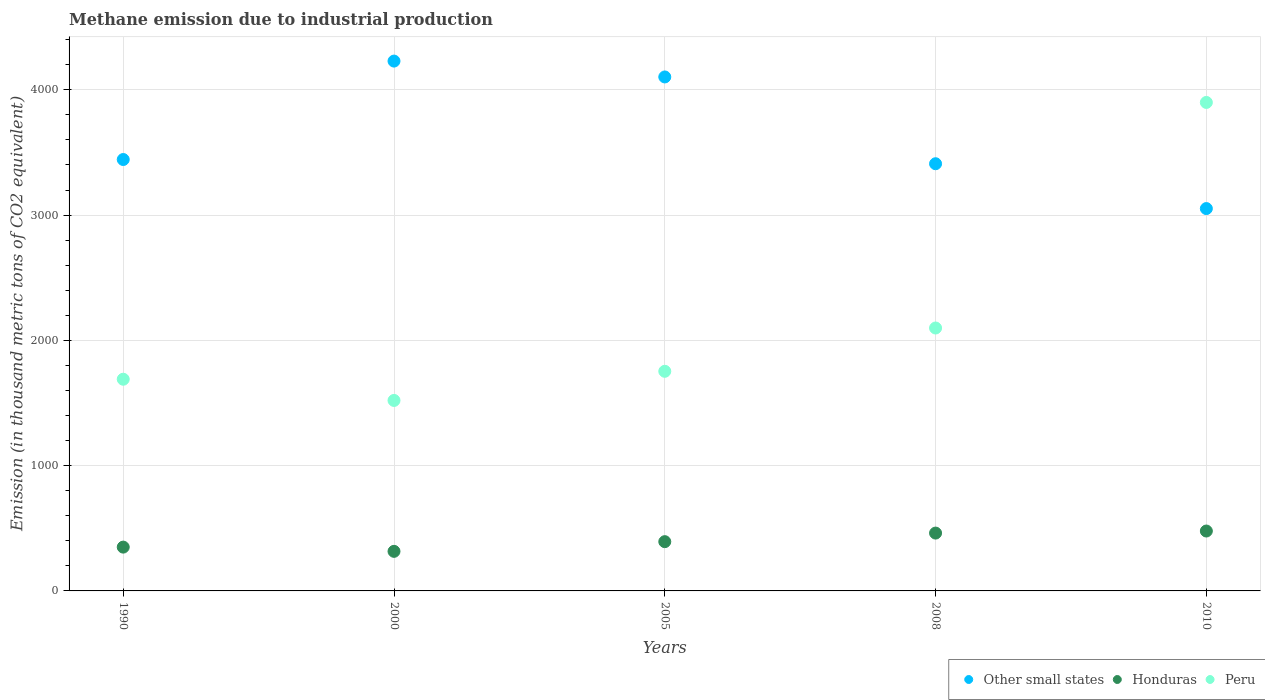Is the number of dotlines equal to the number of legend labels?
Make the answer very short. Yes. What is the amount of methane emitted in Peru in 2000?
Make the answer very short. 1520.5. Across all years, what is the maximum amount of methane emitted in Other small states?
Your answer should be compact. 4229.4. Across all years, what is the minimum amount of methane emitted in Peru?
Your response must be concise. 1520.5. What is the total amount of methane emitted in Peru in the graph?
Keep it short and to the point. 1.10e+04. What is the difference between the amount of methane emitted in Other small states in 2000 and that in 2010?
Keep it short and to the point. 1177.3. What is the difference between the amount of methane emitted in Honduras in 2000 and the amount of methane emitted in Other small states in 2005?
Offer a terse response. -3786.9. What is the average amount of methane emitted in Other small states per year?
Provide a succinct answer. 3647.6. In the year 2010, what is the difference between the amount of methane emitted in Honduras and amount of methane emitted in Peru?
Provide a short and direct response. -3421.2. What is the ratio of the amount of methane emitted in Other small states in 1990 to that in 2010?
Provide a succinct answer. 1.13. Is the amount of methane emitted in Other small states in 1990 less than that in 2008?
Give a very brief answer. No. What is the difference between the highest and the second highest amount of methane emitted in Honduras?
Give a very brief answer. 16.4. What is the difference between the highest and the lowest amount of methane emitted in Other small states?
Offer a terse response. 1177.3. In how many years, is the amount of methane emitted in Other small states greater than the average amount of methane emitted in Other small states taken over all years?
Offer a very short reply. 2. Is the sum of the amount of methane emitted in Other small states in 1990 and 2000 greater than the maximum amount of methane emitted in Honduras across all years?
Your response must be concise. Yes. Is the amount of methane emitted in Peru strictly less than the amount of methane emitted in Other small states over the years?
Offer a terse response. No. How many dotlines are there?
Keep it short and to the point. 3. How are the legend labels stacked?
Offer a terse response. Horizontal. What is the title of the graph?
Offer a very short reply. Methane emission due to industrial production. Does "St. Martin (French part)" appear as one of the legend labels in the graph?
Make the answer very short. No. What is the label or title of the Y-axis?
Ensure brevity in your answer.  Emission (in thousand metric tons of CO2 equivalent). What is the Emission (in thousand metric tons of CO2 equivalent) in Other small states in 1990?
Provide a succinct answer. 3443.7. What is the Emission (in thousand metric tons of CO2 equivalent) in Honduras in 1990?
Your answer should be very brief. 349.7. What is the Emission (in thousand metric tons of CO2 equivalent) of Peru in 1990?
Offer a very short reply. 1689.8. What is the Emission (in thousand metric tons of CO2 equivalent) of Other small states in 2000?
Your response must be concise. 4229.4. What is the Emission (in thousand metric tons of CO2 equivalent) of Honduras in 2000?
Offer a terse response. 315.9. What is the Emission (in thousand metric tons of CO2 equivalent) of Peru in 2000?
Your answer should be very brief. 1520.5. What is the Emission (in thousand metric tons of CO2 equivalent) of Other small states in 2005?
Provide a short and direct response. 4102.8. What is the Emission (in thousand metric tons of CO2 equivalent) of Honduras in 2005?
Provide a short and direct response. 393.2. What is the Emission (in thousand metric tons of CO2 equivalent) of Peru in 2005?
Provide a short and direct response. 1753.1. What is the Emission (in thousand metric tons of CO2 equivalent) of Other small states in 2008?
Your answer should be very brief. 3410. What is the Emission (in thousand metric tons of CO2 equivalent) of Honduras in 2008?
Keep it short and to the point. 461.7. What is the Emission (in thousand metric tons of CO2 equivalent) of Peru in 2008?
Give a very brief answer. 2098.7. What is the Emission (in thousand metric tons of CO2 equivalent) in Other small states in 2010?
Your answer should be compact. 3052.1. What is the Emission (in thousand metric tons of CO2 equivalent) in Honduras in 2010?
Your answer should be very brief. 478.1. What is the Emission (in thousand metric tons of CO2 equivalent) of Peru in 2010?
Your response must be concise. 3899.3. Across all years, what is the maximum Emission (in thousand metric tons of CO2 equivalent) in Other small states?
Keep it short and to the point. 4229.4. Across all years, what is the maximum Emission (in thousand metric tons of CO2 equivalent) of Honduras?
Make the answer very short. 478.1. Across all years, what is the maximum Emission (in thousand metric tons of CO2 equivalent) of Peru?
Provide a short and direct response. 3899.3. Across all years, what is the minimum Emission (in thousand metric tons of CO2 equivalent) in Other small states?
Offer a terse response. 3052.1. Across all years, what is the minimum Emission (in thousand metric tons of CO2 equivalent) in Honduras?
Your answer should be very brief. 315.9. Across all years, what is the minimum Emission (in thousand metric tons of CO2 equivalent) of Peru?
Provide a succinct answer. 1520.5. What is the total Emission (in thousand metric tons of CO2 equivalent) of Other small states in the graph?
Your answer should be very brief. 1.82e+04. What is the total Emission (in thousand metric tons of CO2 equivalent) in Honduras in the graph?
Provide a succinct answer. 1998.6. What is the total Emission (in thousand metric tons of CO2 equivalent) in Peru in the graph?
Provide a succinct answer. 1.10e+04. What is the difference between the Emission (in thousand metric tons of CO2 equivalent) in Other small states in 1990 and that in 2000?
Ensure brevity in your answer.  -785.7. What is the difference between the Emission (in thousand metric tons of CO2 equivalent) of Honduras in 1990 and that in 2000?
Make the answer very short. 33.8. What is the difference between the Emission (in thousand metric tons of CO2 equivalent) of Peru in 1990 and that in 2000?
Your answer should be very brief. 169.3. What is the difference between the Emission (in thousand metric tons of CO2 equivalent) in Other small states in 1990 and that in 2005?
Give a very brief answer. -659.1. What is the difference between the Emission (in thousand metric tons of CO2 equivalent) in Honduras in 1990 and that in 2005?
Provide a short and direct response. -43.5. What is the difference between the Emission (in thousand metric tons of CO2 equivalent) of Peru in 1990 and that in 2005?
Make the answer very short. -63.3. What is the difference between the Emission (in thousand metric tons of CO2 equivalent) in Other small states in 1990 and that in 2008?
Ensure brevity in your answer.  33.7. What is the difference between the Emission (in thousand metric tons of CO2 equivalent) in Honduras in 1990 and that in 2008?
Ensure brevity in your answer.  -112. What is the difference between the Emission (in thousand metric tons of CO2 equivalent) in Peru in 1990 and that in 2008?
Ensure brevity in your answer.  -408.9. What is the difference between the Emission (in thousand metric tons of CO2 equivalent) in Other small states in 1990 and that in 2010?
Offer a very short reply. 391.6. What is the difference between the Emission (in thousand metric tons of CO2 equivalent) of Honduras in 1990 and that in 2010?
Ensure brevity in your answer.  -128.4. What is the difference between the Emission (in thousand metric tons of CO2 equivalent) of Peru in 1990 and that in 2010?
Ensure brevity in your answer.  -2209.5. What is the difference between the Emission (in thousand metric tons of CO2 equivalent) in Other small states in 2000 and that in 2005?
Offer a very short reply. 126.6. What is the difference between the Emission (in thousand metric tons of CO2 equivalent) in Honduras in 2000 and that in 2005?
Your answer should be very brief. -77.3. What is the difference between the Emission (in thousand metric tons of CO2 equivalent) in Peru in 2000 and that in 2005?
Your answer should be very brief. -232.6. What is the difference between the Emission (in thousand metric tons of CO2 equivalent) in Other small states in 2000 and that in 2008?
Provide a succinct answer. 819.4. What is the difference between the Emission (in thousand metric tons of CO2 equivalent) in Honduras in 2000 and that in 2008?
Offer a terse response. -145.8. What is the difference between the Emission (in thousand metric tons of CO2 equivalent) in Peru in 2000 and that in 2008?
Offer a terse response. -578.2. What is the difference between the Emission (in thousand metric tons of CO2 equivalent) in Other small states in 2000 and that in 2010?
Offer a terse response. 1177.3. What is the difference between the Emission (in thousand metric tons of CO2 equivalent) of Honduras in 2000 and that in 2010?
Make the answer very short. -162.2. What is the difference between the Emission (in thousand metric tons of CO2 equivalent) in Peru in 2000 and that in 2010?
Offer a terse response. -2378.8. What is the difference between the Emission (in thousand metric tons of CO2 equivalent) in Other small states in 2005 and that in 2008?
Your answer should be very brief. 692.8. What is the difference between the Emission (in thousand metric tons of CO2 equivalent) of Honduras in 2005 and that in 2008?
Your answer should be very brief. -68.5. What is the difference between the Emission (in thousand metric tons of CO2 equivalent) of Peru in 2005 and that in 2008?
Ensure brevity in your answer.  -345.6. What is the difference between the Emission (in thousand metric tons of CO2 equivalent) in Other small states in 2005 and that in 2010?
Your response must be concise. 1050.7. What is the difference between the Emission (in thousand metric tons of CO2 equivalent) in Honduras in 2005 and that in 2010?
Your response must be concise. -84.9. What is the difference between the Emission (in thousand metric tons of CO2 equivalent) in Peru in 2005 and that in 2010?
Your response must be concise. -2146.2. What is the difference between the Emission (in thousand metric tons of CO2 equivalent) of Other small states in 2008 and that in 2010?
Offer a terse response. 357.9. What is the difference between the Emission (in thousand metric tons of CO2 equivalent) in Honduras in 2008 and that in 2010?
Your answer should be compact. -16.4. What is the difference between the Emission (in thousand metric tons of CO2 equivalent) of Peru in 2008 and that in 2010?
Your answer should be compact. -1800.6. What is the difference between the Emission (in thousand metric tons of CO2 equivalent) in Other small states in 1990 and the Emission (in thousand metric tons of CO2 equivalent) in Honduras in 2000?
Ensure brevity in your answer.  3127.8. What is the difference between the Emission (in thousand metric tons of CO2 equivalent) in Other small states in 1990 and the Emission (in thousand metric tons of CO2 equivalent) in Peru in 2000?
Make the answer very short. 1923.2. What is the difference between the Emission (in thousand metric tons of CO2 equivalent) of Honduras in 1990 and the Emission (in thousand metric tons of CO2 equivalent) of Peru in 2000?
Offer a terse response. -1170.8. What is the difference between the Emission (in thousand metric tons of CO2 equivalent) of Other small states in 1990 and the Emission (in thousand metric tons of CO2 equivalent) of Honduras in 2005?
Give a very brief answer. 3050.5. What is the difference between the Emission (in thousand metric tons of CO2 equivalent) of Other small states in 1990 and the Emission (in thousand metric tons of CO2 equivalent) of Peru in 2005?
Your answer should be very brief. 1690.6. What is the difference between the Emission (in thousand metric tons of CO2 equivalent) in Honduras in 1990 and the Emission (in thousand metric tons of CO2 equivalent) in Peru in 2005?
Your response must be concise. -1403.4. What is the difference between the Emission (in thousand metric tons of CO2 equivalent) in Other small states in 1990 and the Emission (in thousand metric tons of CO2 equivalent) in Honduras in 2008?
Offer a terse response. 2982. What is the difference between the Emission (in thousand metric tons of CO2 equivalent) in Other small states in 1990 and the Emission (in thousand metric tons of CO2 equivalent) in Peru in 2008?
Your response must be concise. 1345. What is the difference between the Emission (in thousand metric tons of CO2 equivalent) of Honduras in 1990 and the Emission (in thousand metric tons of CO2 equivalent) of Peru in 2008?
Your answer should be compact. -1749. What is the difference between the Emission (in thousand metric tons of CO2 equivalent) of Other small states in 1990 and the Emission (in thousand metric tons of CO2 equivalent) of Honduras in 2010?
Provide a succinct answer. 2965.6. What is the difference between the Emission (in thousand metric tons of CO2 equivalent) in Other small states in 1990 and the Emission (in thousand metric tons of CO2 equivalent) in Peru in 2010?
Offer a very short reply. -455.6. What is the difference between the Emission (in thousand metric tons of CO2 equivalent) of Honduras in 1990 and the Emission (in thousand metric tons of CO2 equivalent) of Peru in 2010?
Provide a succinct answer. -3549.6. What is the difference between the Emission (in thousand metric tons of CO2 equivalent) of Other small states in 2000 and the Emission (in thousand metric tons of CO2 equivalent) of Honduras in 2005?
Make the answer very short. 3836.2. What is the difference between the Emission (in thousand metric tons of CO2 equivalent) in Other small states in 2000 and the Emission (in thousand metric tons of CO2 equivalent) in Peru in 2005?
Offer a very short reply. 2476.3. What is the difference between the Emission (in thousand metric tons of CO2 equivalent) in Honduras in 2000 and the Emission (in thousand metric tons of CO2 equivalent) in Peru in 2005?
Provide a succinct answer. -1437.2. What is the difference between the Emission (in thousand metric tons of CO2 equivalent) of Other small states in 2000 and the Emission (in thousand metric tons of CO2 equivalent) of Honduras in 2008?
Ensure brevity in your answer.  3767.7. What is the difference between the Emission (in thousand metric tons of CO2 equivalent) of Other small states in 2000 and the Emission (in thousand metric tons of CO2 equivalent) of Peru in 2008?
Provide a succinct answer. 2130.7. What is the difference between the Emission (in thousand metric tons of CO2 equivalent) of Honduras in 2000 and the Emission (in thousand metric tons of CO2 equivalent) of Peru in 2008?
Offer a very short reply. -1782.8. What is the difference between the Emission (in thousand metric tons of CO2 equivalent) in Other small states in 2000 and the Emission (in thousand metric tons of CO2 equivalent) in Honduras in 2010?
Your answer should be compact. 3751.3. What is the difference between the Emission (in thousand metric tons of CO2 equivalent) of Other small states in 2000 and the Emission (in thousand metric tons of CO2 equivalent) of Peru in 2010?
Your response must be concise. 330.1. What is the difference between the Emission (in thousand metric tons of CO2 equivalent) in Honduras in 2000 and the Emission (in thousand metric tons of CO2 equivalent) in Peru in 2010?
Your answer should be very brief. -3583.4. What is the difference between the Emission (in thousand metric tons of CO2 equivalent) in Other small states in 2005 and the Emission (in thousand metric tons of CO2 equivalent) in Honduras in 2008?
Ensure brevity in your answer.  3641.1. What is the difference between the Emission (in thousand metric tons of CO2 equivalent) of Other small states in 2005 and the Emission (in thousand metric tons of CO2 equivalent) of Peru in 2008?
Your answer should be very brief. 2004.1. What is the difference between the Emission (in thousand metric tons of CO2 equivalent) of Honduras in 2005 and the Emission (in thousand metric tons of CO2 equivalent) of Peru in 2008?
Make the answer very short. -1705.5. What is the difference between the Emission (in thousand metric tons of CO2 equivalent) of Other small states in 2005 and the Emission (in thousand metric tons of CO2 equivalent) of Honduras in 2010?
Ensure brevity in your answer.  3624.7. What is the difference between the Emission (in thousand metric tons of CO2 equivalent) in Other small states in 2005 and the Emission (in thousand metric tons of CO2 equivalent) in Peru in 2010?
Provide a succinct answer. 203.5. What is the difference between the Emission (in thousand metric tons of CO2 equivalent) of Honduras in 2005 and the Emission (in thousand metric tons of CO2 equivalent) of Peru in 2010?
Give a very brief answer. -3506.1. What is the difference between the Emission (in thousand metric tons of CO2 equivalent) of Other small states in 2008 and the Emission (in thousand metric tons of CO2 equivalent) of Honduras in 2010?
Provide a short and direct response. 2931.9. What is the difference between the Emission (in thousand metric tons of CO2 equivalent) of Other small states in 2008 and the Emission (in thousand metric tons of CO2 equivalent) of Peru in 2010?
Make the answer very short. -489.3. What is the difference between the Emission (in thousand metric tons of CO2 equivalent) of Honduras in 2008 and the Emission (in thousand metric tons of CO2 equivalent) of Peru in 2010?
Offer a terse response. -3437.6. What is the average Emission (in thousand metric tons of CO2 equivalent) of Other small states per year?
Make the answer very short. 3647.6. What is the average Emission (in thousand metric tons of CO2 equivalent) in Honduras per year?
Your response must be concise. 399.72. What is the average Emission (in thousand metric tons of CO2 equivalent) in Peru per year?
Keep it short and to the point. 2192.28. In the year 1990, what is the difference between the Emission (in thousand metric tons of CO2 equivalent) in Other small states and Emission (in thousand metric tons of CO2 equivalent) in Honduras?
Give a very brief answer. 3094. In the year 1990, what is the difference between the Emission (in thousand metric tons of CO2 equivalent) in Other small states and Emission (in thousand metric tons of CO2 equivalent) in Peru?
Offer a terse response. 1753.9. In the year 1990, what is the difference between the Emission (in thousand metric tons of CO2 equivalent) in Honduras and Emission (in thousand metric tons of CO2 equivalent) in Peru?
Give a very brief answer. -1340.1. In the year 2000, what is the difference between the Emission (in thousand metric tons of CO2 equivalent) of Other small states and Emission (in thousand metric tons of CO2 equivalent) of Honduras?
Make the answer very short. 3913.5. In the year 2000, what is the difference between the Emission (in thousand metric tons of CO2 equivalent) of Other small states and Emission (in thousand metric tons of CO2 equivalent) of Peru?
Make the answer very short. 2708.9. In the year 2000, what is the difference between the Emission (in thousand metric tons of CO2 equivalent) of Honduras and Emission (in thousand metric tons of CO2 equivalent) of Peru?
Offer a terse response. -1204.6. In the year 2005, what is the difference between the Emission (in thousand metric tons of CO2 equivalent) of Other small states and Emission (in thousand metric tons of CO2 equivalent) of Honduras?
Keep it short and to the point. 3709.6. In the year 2005, what is the difference between the Emission (in thousand metric tons of CO2 equivalent) of Other small states and Emission (in thousand metric tons of CO2 equivalent) of Peru?
Make the answer very short. 2349.7. In the year 2005, what is the difference between the Emission (in thousand metric tons of CO2 equivalent) of Honduras and Emission (in thousand metric tons of CO2 equivalent) of Peru?
Provide a succinct answer. -1359.9. In the year 2008, what is the difference between the Emission (in thousand metric tons of CO2 equivalent) of Other small states and Emission (in thousand metric tons of CO2 equivalent) of Honduras?
Your response must be concise. 2948.3. In the year 2008, what is the difference between the Emission (in thousand metric tons of CO2 equivalent) of Other small states and Emission (in thousand metric tons of CO2 equivalent) of Peru?
Your answer should be compact. 1311.3. In the year 2008, what is the difference between the Emission (in thousand metric tons of CO2 equivalent) in Honduras and Emission (in thousand metric tons of CO2 equivalent) in Peru?
Offer a terse response. -1637. In the year 2010, what is the difference between the Emission (in thousand metric tons of CO2 equivalent) in Other small states and Emission (in thousand metric tons of CO2 equivalent) in Honduras?
Give a very brief answer. 2574. In the year 2010, what is the difference between the Emission (in thousand metric tons of CO2 equivalent) in Other small states and Emission (in thousand metric tons of CO2 equivalent) in Peru?
Your answer should be compact. -847.2. In the year 2010, what is the difference between the Emission (in thousand metric tons of CO2 equivalent) in Honduras and Emission (in thousand metric tons of CO2 equivalent) in Peru?
Your answer should be compact. -3421.2. What is the ratio of the Emission (in thousand metric tons of CO2 equivalent) in Other small states in 1990 to that in 2000?
Ensure brevity in your answer.  0.81. What is the ratio of the Emission (in thousand metric tons of CO2 equivalent) in Honduras in 1990 to that in 2000?
Keep it short and to the point. 1.11. What is the ratio of the Emission (in thousand metric tons of CO2 equivalent) of Peru in 1990 to that in 2000?
Your answer should be compact. 1.11. What is the ratio of the Emission (in thousand metric tons of CO2 equivalent) of Other small states in 1990 to that in 2005?
Offer a very short reply. 0.84. What is the ratio of the Emission (in thousand metric tons of CO2 equivalent) in Honduras in 1990 to that in 2005?
Your answer should be very brief. 0.89. What is the ratio of the Emission (in thousand metric tons of CO2 equivalent) in Peru in 1990 to that in 2005?
Your response must be concise. 0.96. What is the ratio of the Emission (in thousand metric tons of CO2 equivalent) of Other small states in 1990 to that in 2008?
Offer a terse response. 1.01. What is the ratio of the Emission (in thousand metric tons of CO2 equivalent) of Honduras in 1990 to that in 2008?
Make the answer very short. 0.76. What is the ratio of the Emission (in thousand metric tons of CO2 equivalent) in Peru in 1990 to that in 2008?
Offer a terse response. 0.81. What is the ratio of the Emission (in thousand metric tons of CO2 equivalent) of Other small states in 1990 to that in 2010?
Provide a succinct answer. 1.13. What is the ratio of the Emission (in thousand metric tons of CO2 equivalent) in Honduras in 1990 to that in 2010?
Provide a short and direct response. 0.73. What is the ratio of the Emission (in thousand metric tons of CO2 equivalent) of Peru in 1990 to that in 2010?
Your answer should be very brief. 0.43. What is the ratio of the Emission (in thousand metric tons of CO2 equivalent) in Other small states in 2000 to that in 2005?
Provide a succinct answer. 1.03. What is the ratio of the Emission (in thousand metric tons of CO2 equivalent) of Honduras in 2000 to that in 2005?
Give a very brief answer. 0.8. What is the ratio of the Emission (in thousand metric tons of CO2 equivalent) of Peru in 2000 to that in 2005?
Offer a very short reply. 0.87. What is the ratio of the Emission (in thousand metric tons of CO2 equivalent) in Other small states in 2000 to that in 2008?
Your response must be concise. 1.24. What is the ratio of the Emission (in thousand metric tons of CO2 equivalent) in Honduras in 2000 to that in 2008?
Ensure brevity in your answer.  0.68. What is the ratio of the Emission (in thousand metric tons of CO2 equivalent) in Peru in 2000 to that in 2008?
Your answer should be very brief. 0.72. What is the ratio of the Emission (in thousand metric tons of CO2 equivalent) of Other small states in 2000 to that in 2010?
Your answer should be compact. 1.39. What is the ratio of the Emission (in thousand metric tons of CO2 equivalent) of Honduras in 2000 to that in 2010?
Your answer should be very brief. 0.66. What is the ratio of the Emission (in thousand metric tons of CO2 equivalent) in Peru in 2000 to that in 2010?
Your answer should be very brief. 0.39. What is the ratio of the Emission (in thousand metric tons of CO2 equivalent) in Other small states in 2005 to that in 2008?
Your response must be concise. 1.2. What is the ratio of the Emission (in thousand metric tons of CO2 equivalent) of Honduras in 2005 to that in 2008?
Provide a short and direct response. 0.85. What is the ratio of the Emission (in thousand metric tons of CO2 equivalent) of Peru in 2005 to that in 2008?
Ensure brevity in your answer.  0.84. What is the ratio of the Emission (in thousand metric tons of CO2 equivalent) of Other small states in 2005 to that in 2010?
Give a very brief answer. 1.34. What is the ratio of the Emission (in thousand metric tons of CO2 equivalent) of Honduras in 2005 to that in 2010?
Make the answer very short. 0.82. What is the ratio of the Emission (in thousand metric tons of CO2 equivalent) of Peru in 2005 to that in 2010?
Offer a terse response. 0.45. What is the ratio of the Emission (in thousand metric tons of CO2 equivalent) in Other small states in 2008 to that in 2010?
Ensure brevity in your answer.  1.12. What is the ratio of the Emission (in thousand metric tons of CO2 equivalent) of Honduras in 2008 to that in 2010?
Offer a very short reply. 0.97. What is the ratio of the Emission (in thousand metric tons of CO2 equivalent) of Peru in 2008 to that in 2010?
Your response must be concise. 0.54. What is the difference between the highest and the second highest Emission (in thousand metric tons of CO2 equivalent) of Other small states?
Your response must be concise. 126.6. What is the difference between the highest and the second highest Emission (in thousand metric tons of CO2 equivalent) of Peru?
Keep it short and to the point. 1800.6. What is the difference between the highest and the lowest Emission (in thousand metric tons of CO2 equivalent) of Other small states?
Make the answer very short. 1177.3. What is the difference between the highest and the lowest Emission (in thousand metric tons of CO2 equivalent) of Honduras?
Ensure brevity in your answer.  162.2. What is the difference between the highest and the lowest Emission (in thousand metric tons of CO2 equivalent) in Peru?
Ensure brevity in your answer.  2378.8. 